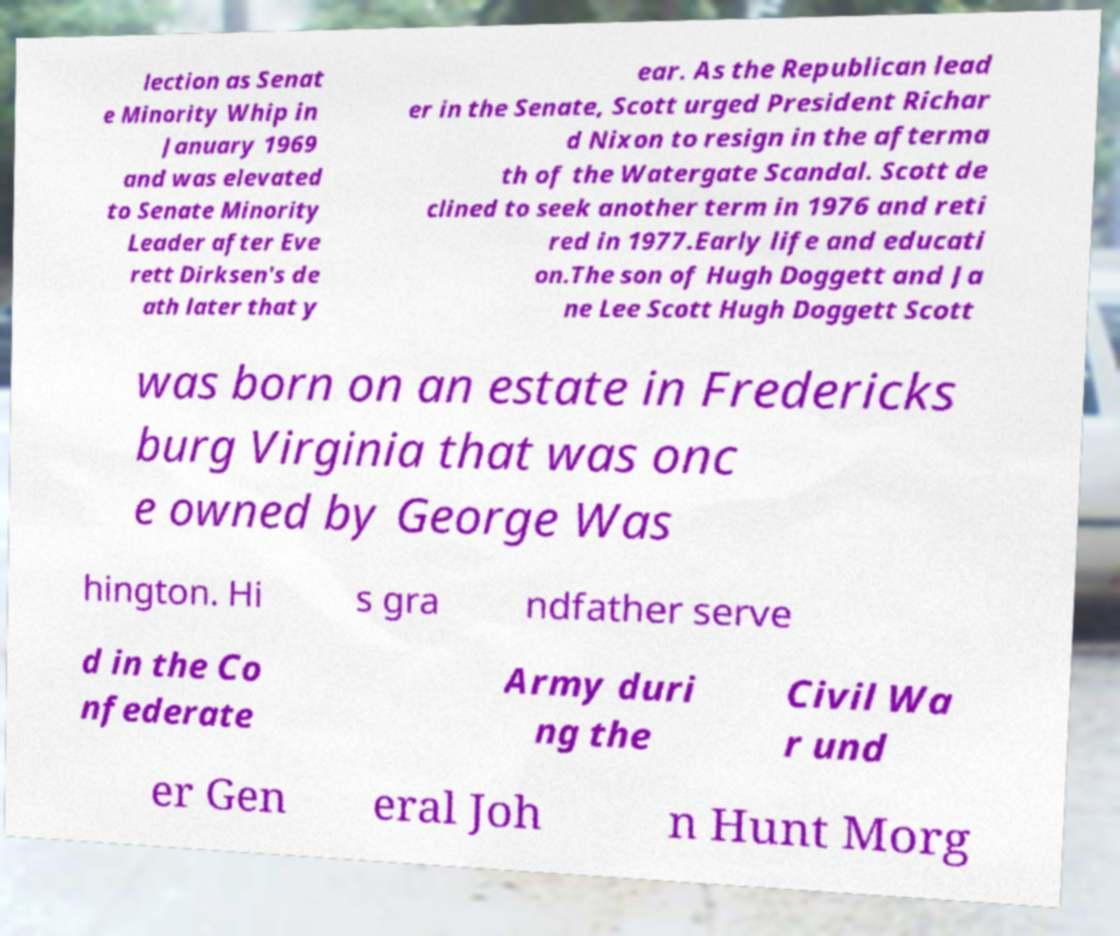For documentation purposes, I need the text within this image transcribed. Could you provide that? lection as Senat e Minority Whip in January 1969 and was elevated to Senate Minority Leader after Eve rett Dirksen's de ath later that y ear. As the Republican lead er in the Senate, Scott urged President Richar d Nixon to resign in the afterma th of the Watergate Scandal. Scott de clined to seek another term in 1976 and reti red in 1977.Early life and educati on.The son of Hugh Doggett and Ja ne Lee Scott Hugh Doggett Scott was born on an estate in Fredericks burg Virginia that was onc e owned by George Was hington. Hi s gra ndfather serve d in the Co nfederate Army duri ng the Civil Wa r und er Gen eral Joh n Hunt Morg 